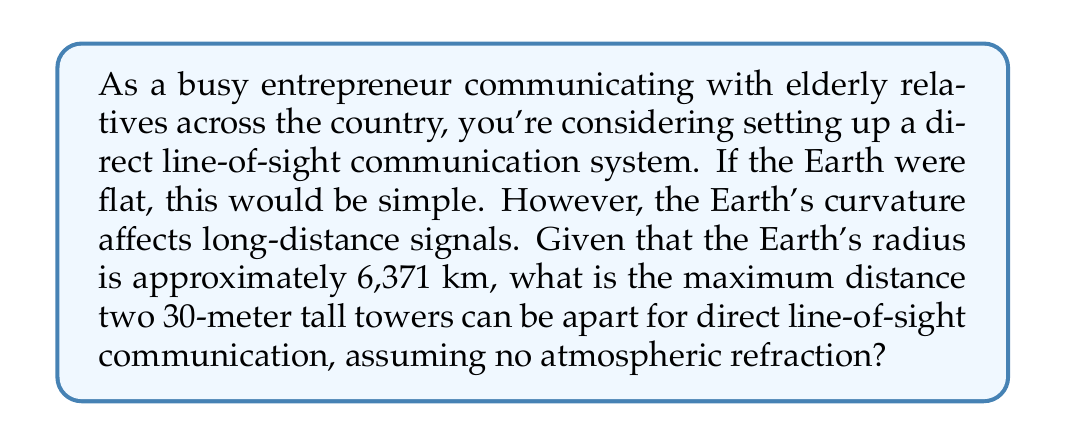Help me with this question. To solve this problem, we need to consider the geometry of the Earth's curvature. Let's break it down step-by-step:

1) First, we need to visualize the problem. Imagine a right triangle formed by:
   - The center of the Earth
   - The base of the tower
   - The point where the line-of-sight from the top of the tower touches the Earth's surface

2) In this triangle:
   - The hypotenuse is the Earth's radius (R) plus the tower height (h)
   - One side is the Earth's radius (R)
   - The other side is the distance (d) from the tower to the point where the line-of-sight touches the Earth

3) We can use the Pythagorean theorem:

   $$(R + h)^2 = R^2 + d^2$$

4) Expanding this:

   $$R^2 + 2Rh + h^2 = R^2 + d^2$$

5) Simplifying:

   $$2Rh + h^2 = d^2$$

6) Since h is much smaller than R, we can neglect $h^2$:

   $$2Rh \approx d^2$$

7) Solving for d:

   $$d \approx \sqrt{2Rh}$$

8) Now, let's plug in our values:
   R = 6,371,000 m (Earth's radius)
   h = 30 m (tower height)

   $$d \approx \sqrt{2 * 6,371,000 * 30} \approx 19,545 \text{ m}$$

9) This is the distance from one tower to the horizon. For two towers, we double this distance:

   $$\text{Total distance} \approx 2 * 19,545 \approx 39,090 \text{ m} \approx 39.1 \text{ km}$$

Therefore, the maximum distance between two 30-meter tall towers for direct line-of-sight communication is approximately 39.1 km.

[asy]
import geometry;

size(200);
pair O = (0,0);
real R = 5;
real h = 0.5;
real d = sqrt(2*R*h);

draw(circle(O,R));
draw((-d-1,0)--(d+1,0));
draw((0,R)--(0,R+h));
draw((0,R+h)--(d,R));
draw(O--(0,R+h));
draw(O--(d,R), dashed);

label("O",O,SW);
label("R",((0,R)+O)/2,W);
label("h",(0,R+h/2),E);
label("d",(d/2,R),N);

[/asy]
Answer: The maximum distance between two 30-meter tall towers for direct line-of-sight communication, considering the Earth's curvature, is approximately 39.1 km. 